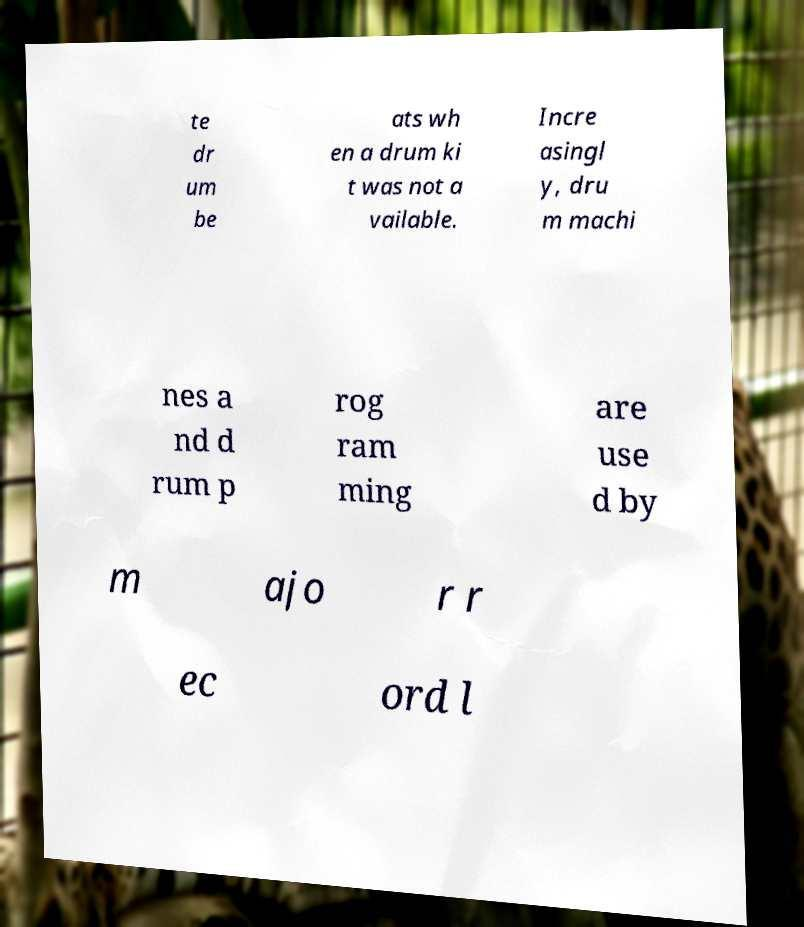For documentation purposes, I need the text within this image transcribed. Could you provide that? te dr um be ats wh en a drum ki t was not a vailable. Incre asingl y, dru m machi nes a nd d rum p rog ram ming are use d by m ajo r r ec ord l 